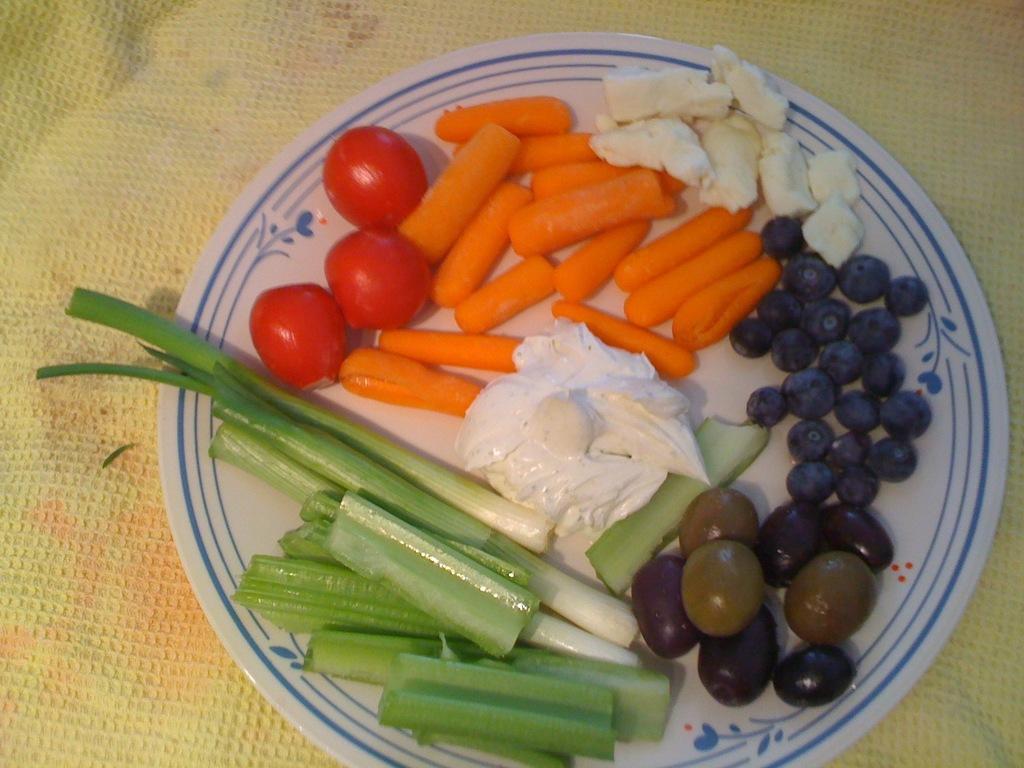Could you give a brief overview of what you see in this image? In this image I can see some food items in the plate. I can also see the background is cream in color. 